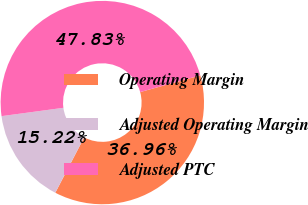Convert chart to OTSL. <chart><loc_0><loc_0><loc_500><loc_500><pie_chart><fcel>Operating Margin<fcel>Adjusted Operating Margin<fcel>Adjusted PTC<nl><fcel>36.96%<fcel>15.22%<fcel>47.83%<nl></chart> 